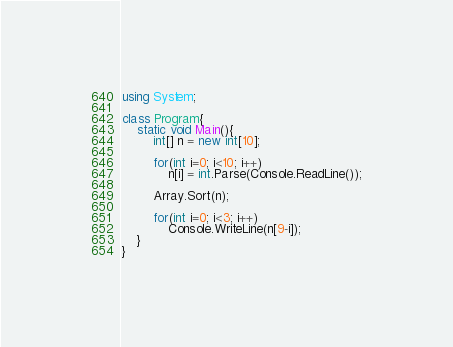<code> <loc_0><loc_0><loc_500><loc_500><_C#_>using System;

class Program{
	static void Main(){
		int[] n = new int[10];

		for(int i=0; i<10; i++)
			n[i] = int.Parse(Console.ReadLine());

		Array.Sort(n);

		for(int i=0; i<3; i++)
			Console.WriteLine(n[9-i]);
	}
}</code> 